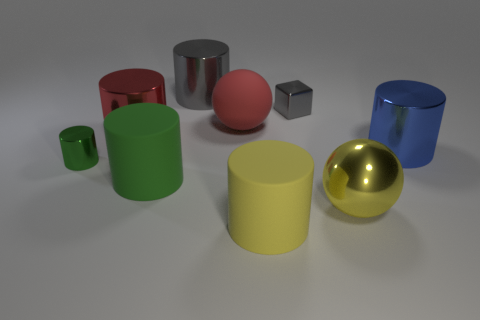Is the color of the rubber cylinder that is on the right side of the red rubber ball the same as the big metal ball?
Offer a very short reply. Yes. How many green things are either small cylinders or large metallic spheres?
Provide a short and direct response. 1. How many small objects are the same color as the small cylinder?
Offer a very short reply. 0. Are the small block and the big yellow cylinder made of the same material?
Offer a terse response. No. There is a big matte cylinder that is on the right side of the big gray shiny thing; what number of big blue metal cylinders are to the left of it?
Provide a short and direct response. 0. Is the size of the yellow rubber cylinder the same as the red metallic cylinder?
Ensure brevity in your answer.  Yes. What number of large gray cylinders have the same material as the tiny gray cube?
Provide a succinct answer. 1. What size is the red metal object that is the same shape as the large gray object?
Give a very brief answer. Large. Is the shape of the tiny metal thing that is on the left side of the green rubber thing the same as  the large green matte thing?
Ensure brevity in your answer.  Yes. What shape is the tiny thing that is to the left of the rubber object behind the blue metallic cylinder?
Offer a very short reply. Cylinder. 